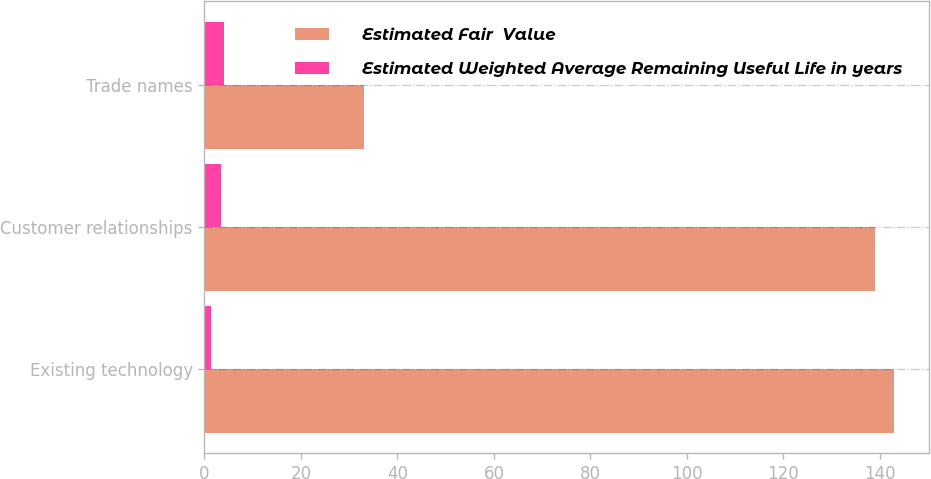Convert chart to OTSL. <chart><loc_0><loc_0><loc_500><loc_500><stacked_bar_chart><ecel><fcel>Existing technology<fcel>Customer relationships<fcel>Trade names<nl><fcel>Estimated Fair  Value<fcel>143<fcel>139<fcel>33<nl><fcel>Estimated Weighted Average Remaining Useful Life in years<fcel>1.4<fcel>3.5<fcel>4<nl></chart> 